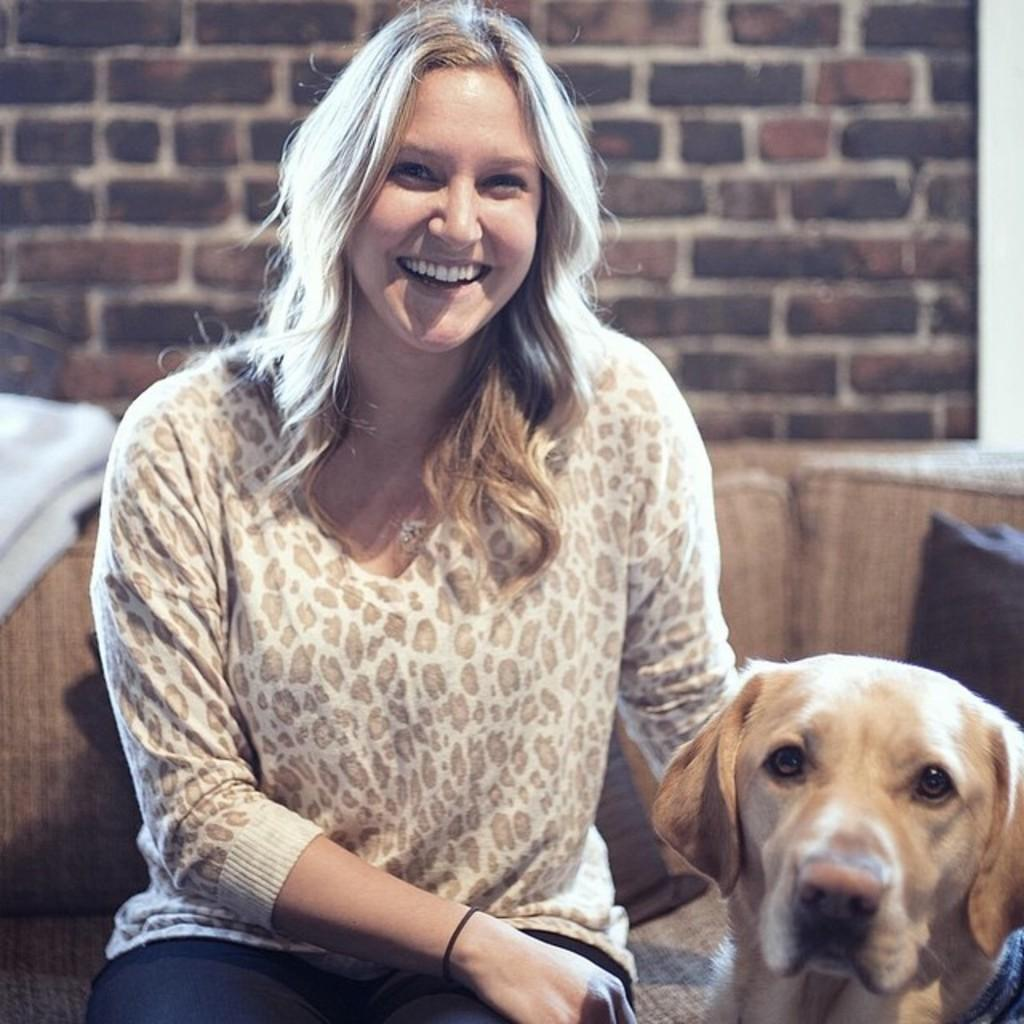Who is present in the image? There is a woman in the image. What is the woman doing in the image? The woman is sitting on a sofa and smiling. Is there any other living creature in the image? Yes, there is a dog in the image. Where is the dog located in relation to the woman? The dog is beside the woman. What can be seen behind the sofa? There is a wall with bricks in the image. What type of flesh can be seen on the woman's face in the image? There is no indication of any flesh on the woman's face in the image; she is simply smiling. 